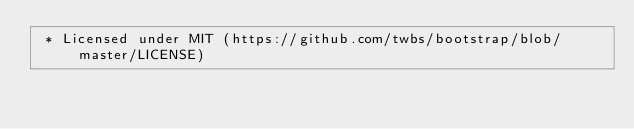<code> <loc_0><loc_0><loc_500><loc_500><_CSS_> * Licensed under MIT (https://github.com/twbs/bootstrap/blob/master/LICENSE)</code> 